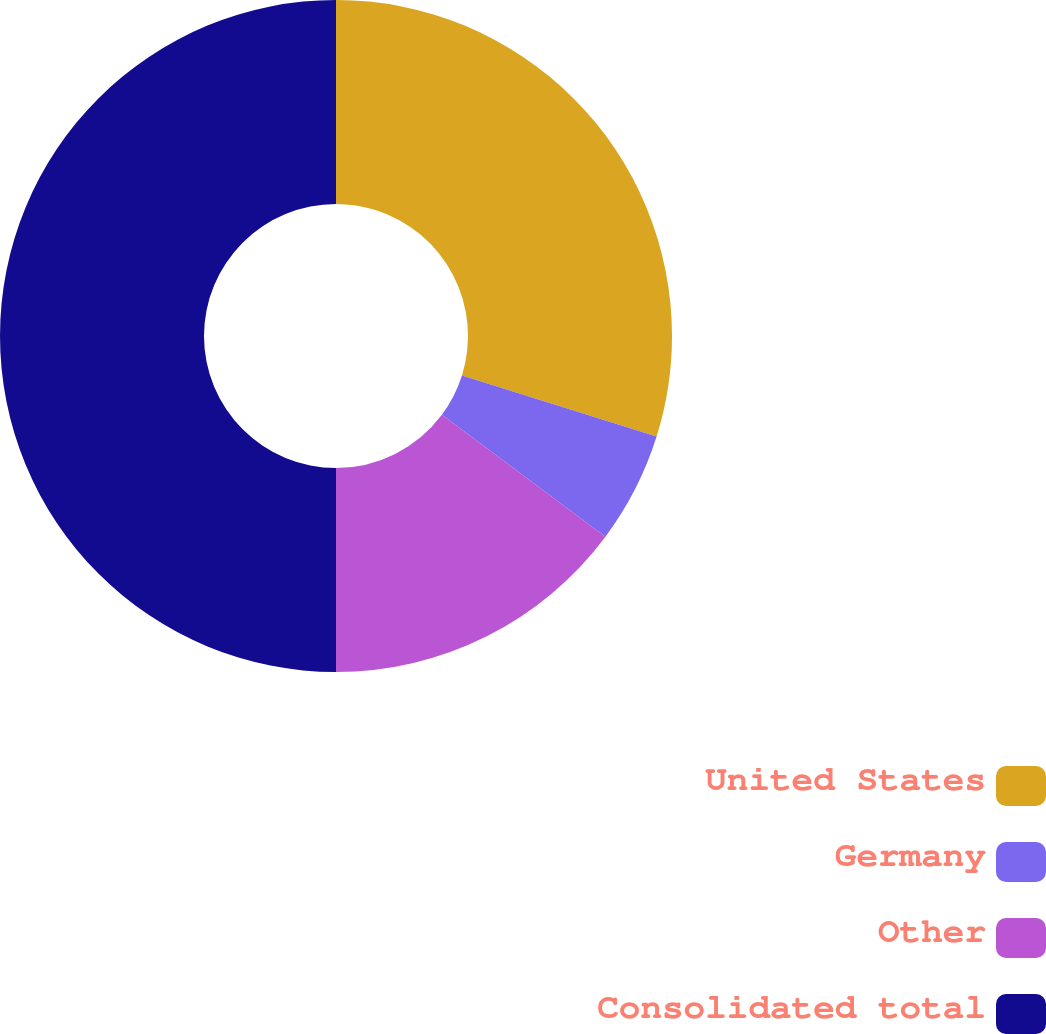<chart> <loc_0><loc_0><loc_500><loc_500><pie_chart><fcel>United States<fcel>Germany<fcel>Other<fcel>Consolidated total<nl><fcel>29.84%<fcel>5.35%<fcel>14.81%<fcel>50.0%<nl></chart> 